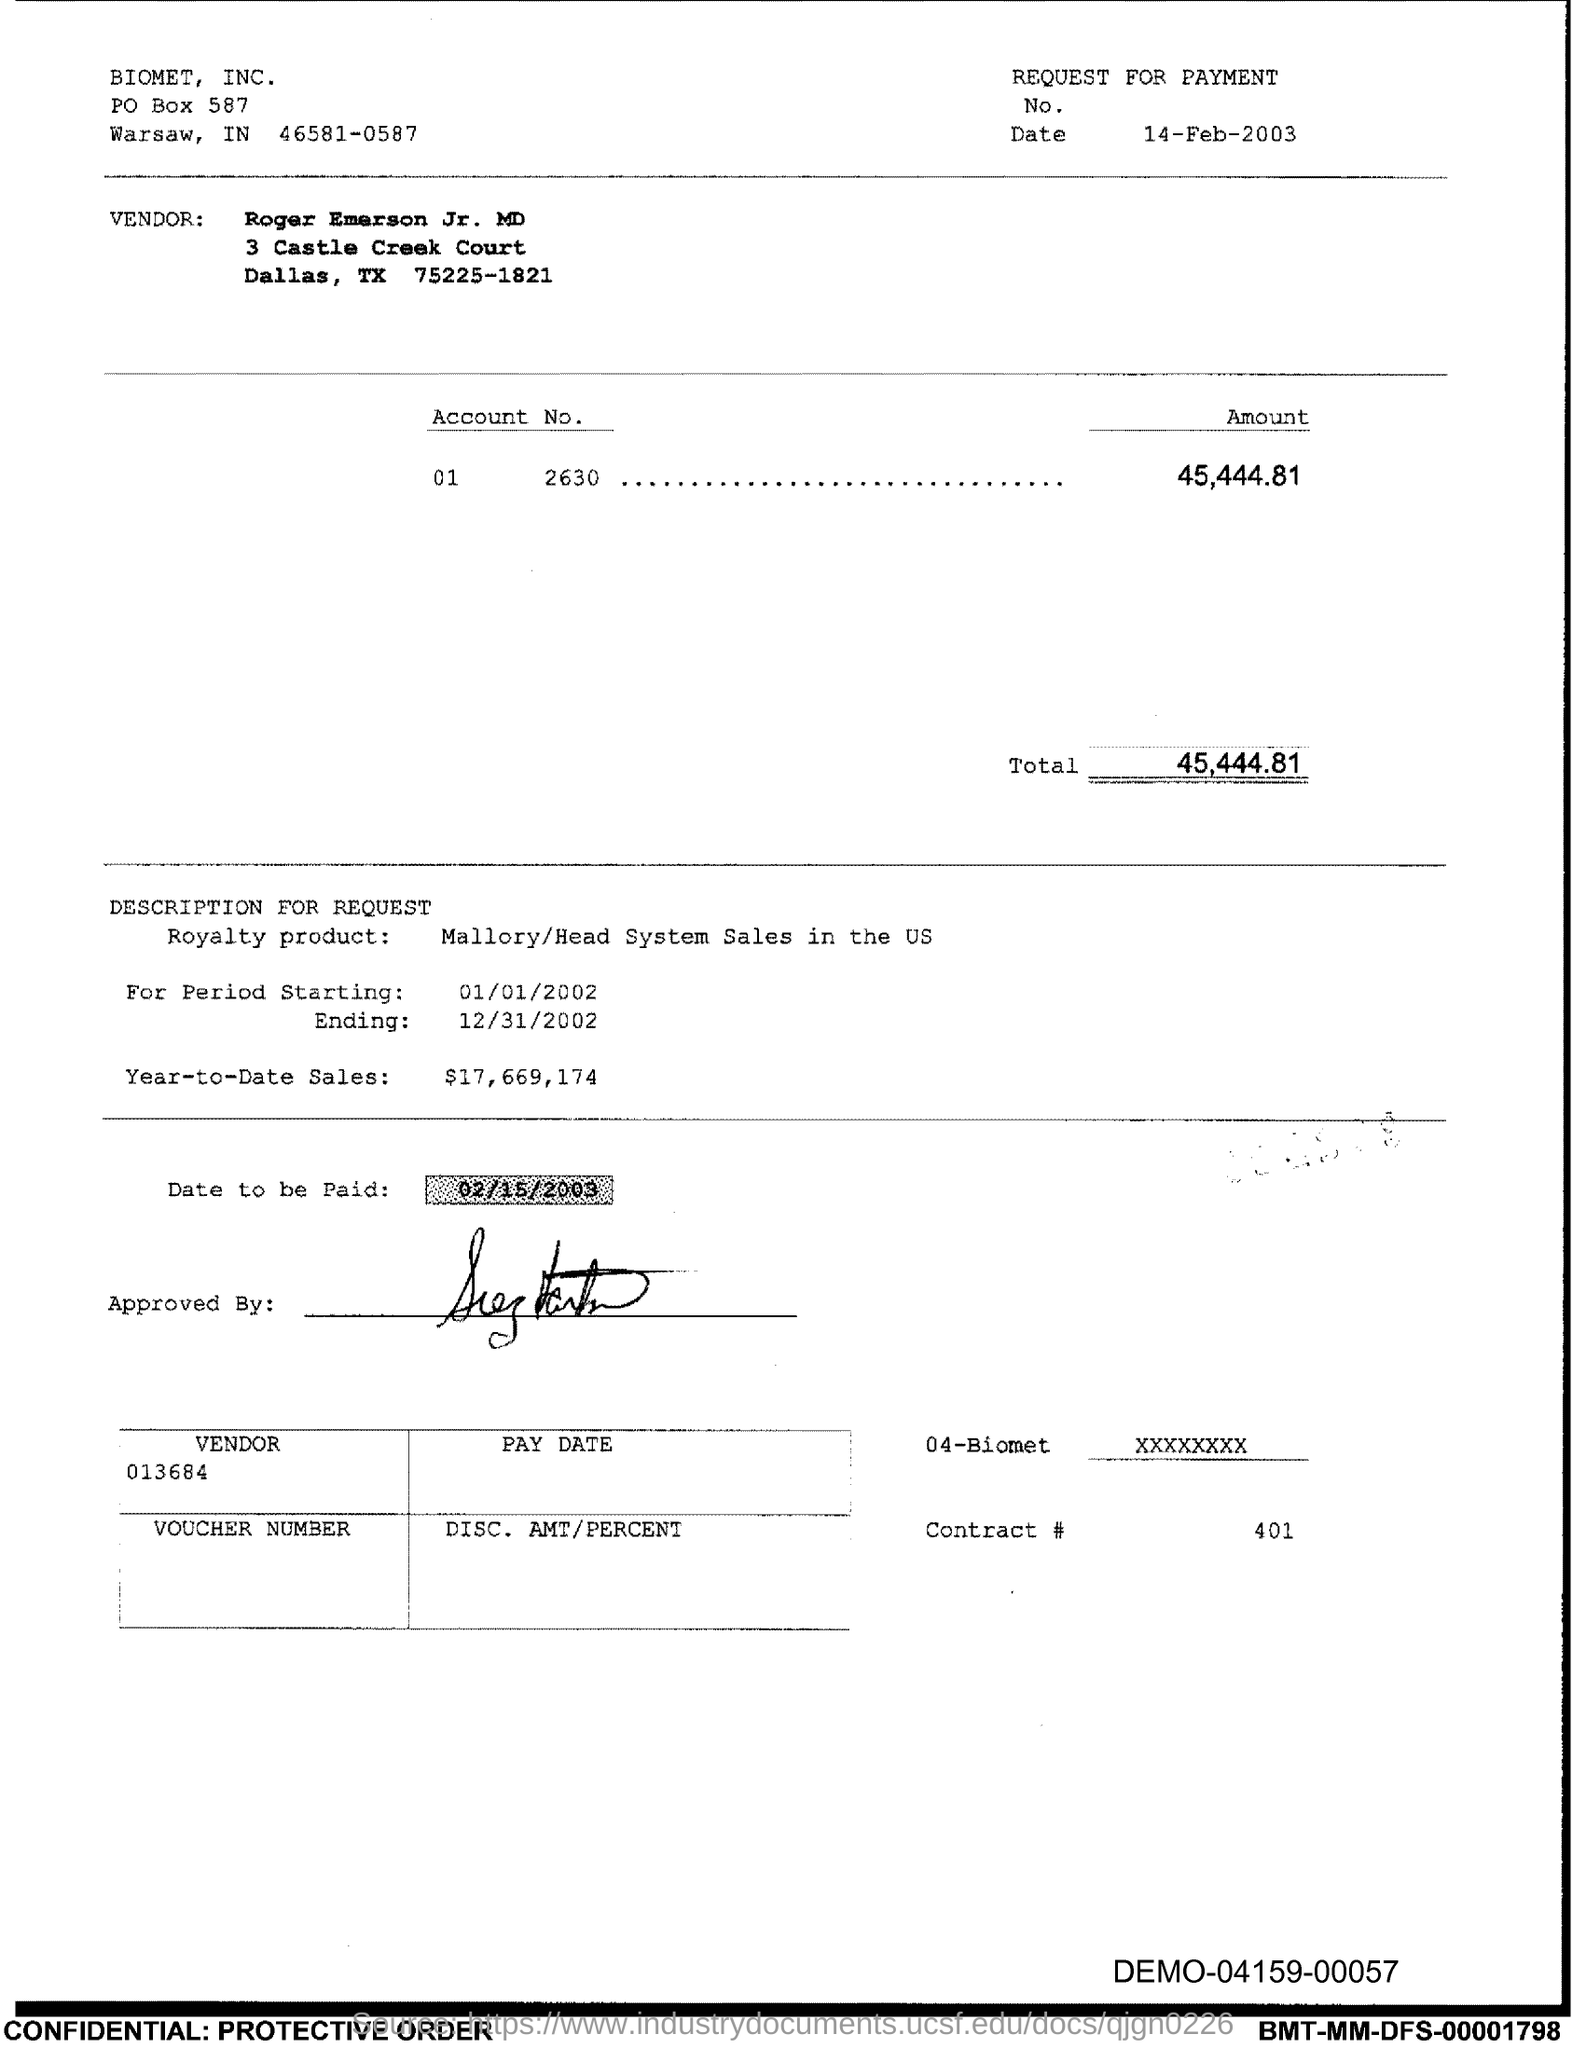Highlight a few significant elements in this photo. The total is 45,444.81 The Contract # Number is 401. 